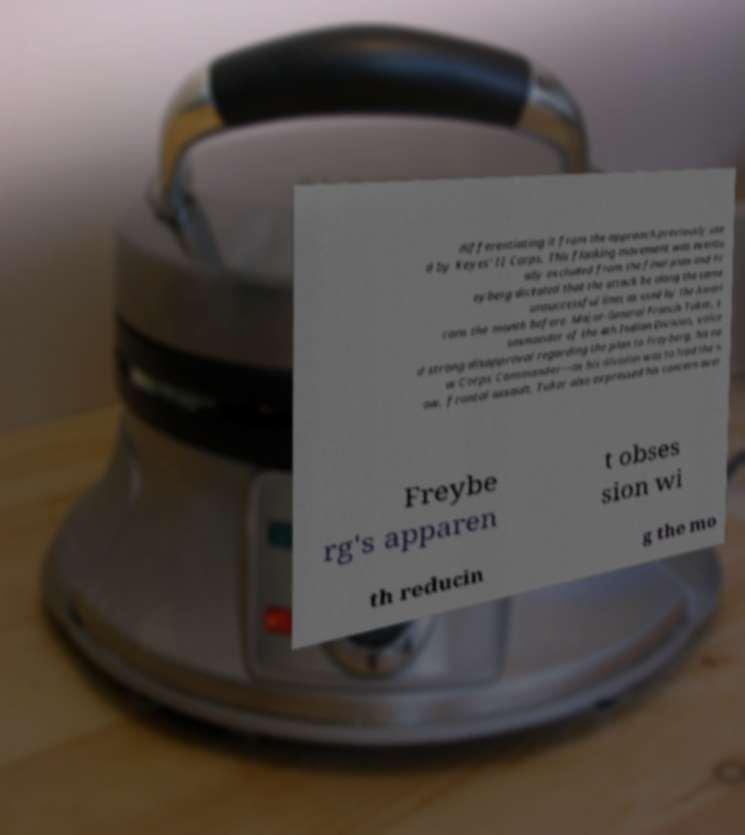Could you extract and type out the text from this image? differentiating it from the approach previously use d by Keyes' II Corps. This flanking movement was eventu ally excluded from the final plan and Fr eyberg dictated that the attack be along the same unsuccessful lines as used by the Ameri cans the month before. Major-General Francis Tuker, c ommander of the 4th Indian Division, voice d strong disapproval regarding the plan to Freyberg, his ne w Corps Commander—as his division was to lead the n ow, frontal assault. Tuker also expressed his concern over Freybe rg's apparen t obses sion wi th reducin g the mo 